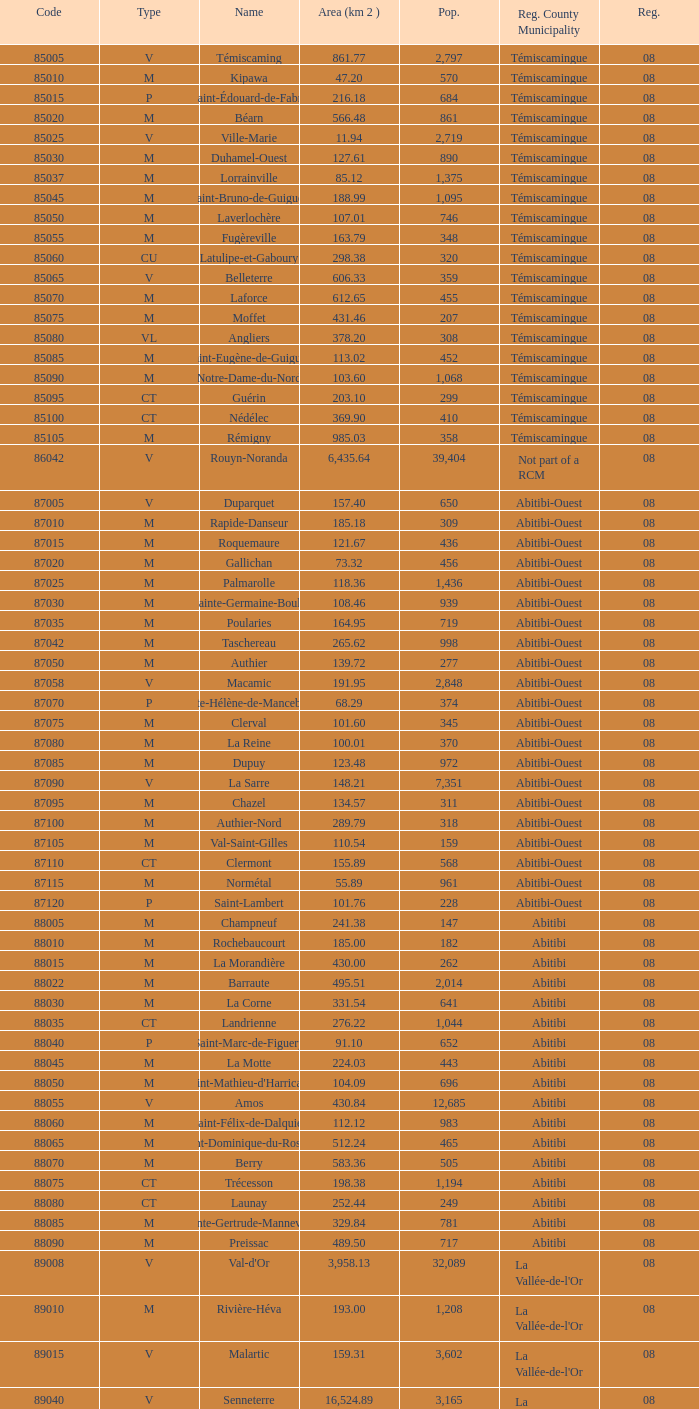What was the region for Malartic with 159.31 km2? 0.0. 